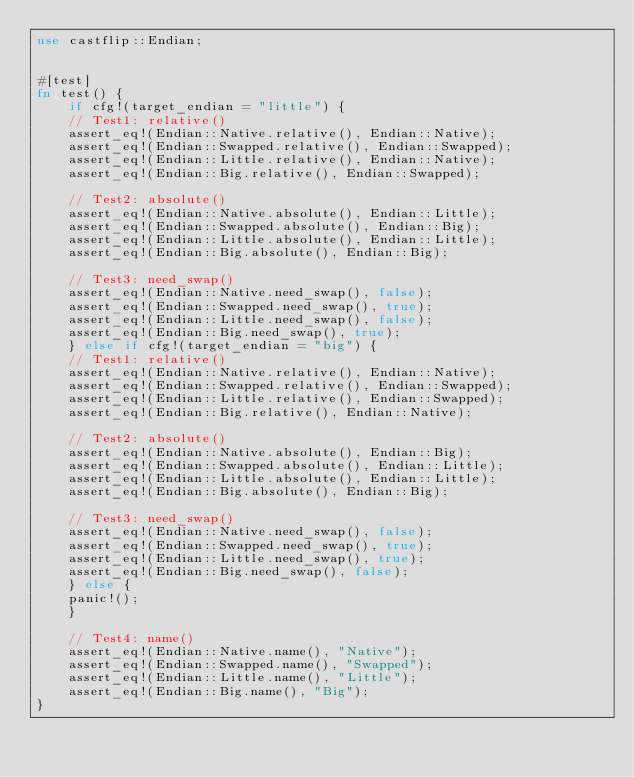<code> <loc_0><loc_0><loc_500><loc_500><_Rust_>use castflip::Endian;


#[test]
fn test() {
    if cfg!(target_endian = "little") {
	// Test1: relative()
	assert_eq!(Endian::Native.relative(), Endian::Native);
	assert_eq!(Endian::Swapped.relative(), Endian::Swapped);
	assert_eq!(Endian::Little.relative(), Endian::Native);
	assert_eq!(Endian::Big.relative(), Endian::Swapped);

	// Test2: absolute()
	assert_eq!(Endian::Native.absolute(), Endian::Little);
	assert_eq!(Endian::Swapped.absolute(), Endian::Big);
	assert_eq!(Endian::Little.absolute(), Endian::Little);
	assert_eq!(Endian::Big.absolute(), Endian::Big);

	// Test3: need_swap()
	assert_eq!(Endian::Native.need_swap(), false);
	assert_eq!(Endian::Swapped.need_swap(), true);
	assert_eq!(Endian::Little.need_swap(), false);
	assert_eq!(Endian::Big.need_swap(), true);
    } else if cfg!(target_endian = "big") {
	// Test1: relative()
	assert_eq!(Endian::Native.relative(), Endian::Native);
	assert_eq!(Endian::Swapped.relative(), Endian::Swapped);
	assert_eq!(Endian::Little.relative(), Endian::Swapped);
	assert_eq!(Endian::Big.relative(), Endian::Native);

	// Test2: absolute()
	assert_eq!(Endian::Native.absolute(), Endian::Big);
	assert_eq!(Endian::Swapped.absolute(), Endian::Little);
	assert_eq!(Endian::Little.absolute(), Endian::Little);
	assert_eq!(Endian::Big.absolute(), Endian::Big);

	// Test3: need_swap()
	assert_eq!(Endian::Native.need_swap(), false);
	assert_eq!(Endian::Swapped.need_swap(), true);
	assert_eq!(Endian::Little.need_swap(), true);
	assert_eq!(Endian::Big.need_swap(), false);
    } else {
	panic!();
    }

    // Test4: name()
    assert_eq!(Endian::Native.name(), "Native");
    assert_eq!(Endian::Swapped.name(), "Swapped");
    assert_eq!(Endian::Little.name(), "Little");
    assert_eq!(Endian::Big.name(), "Big");
}
</code> 